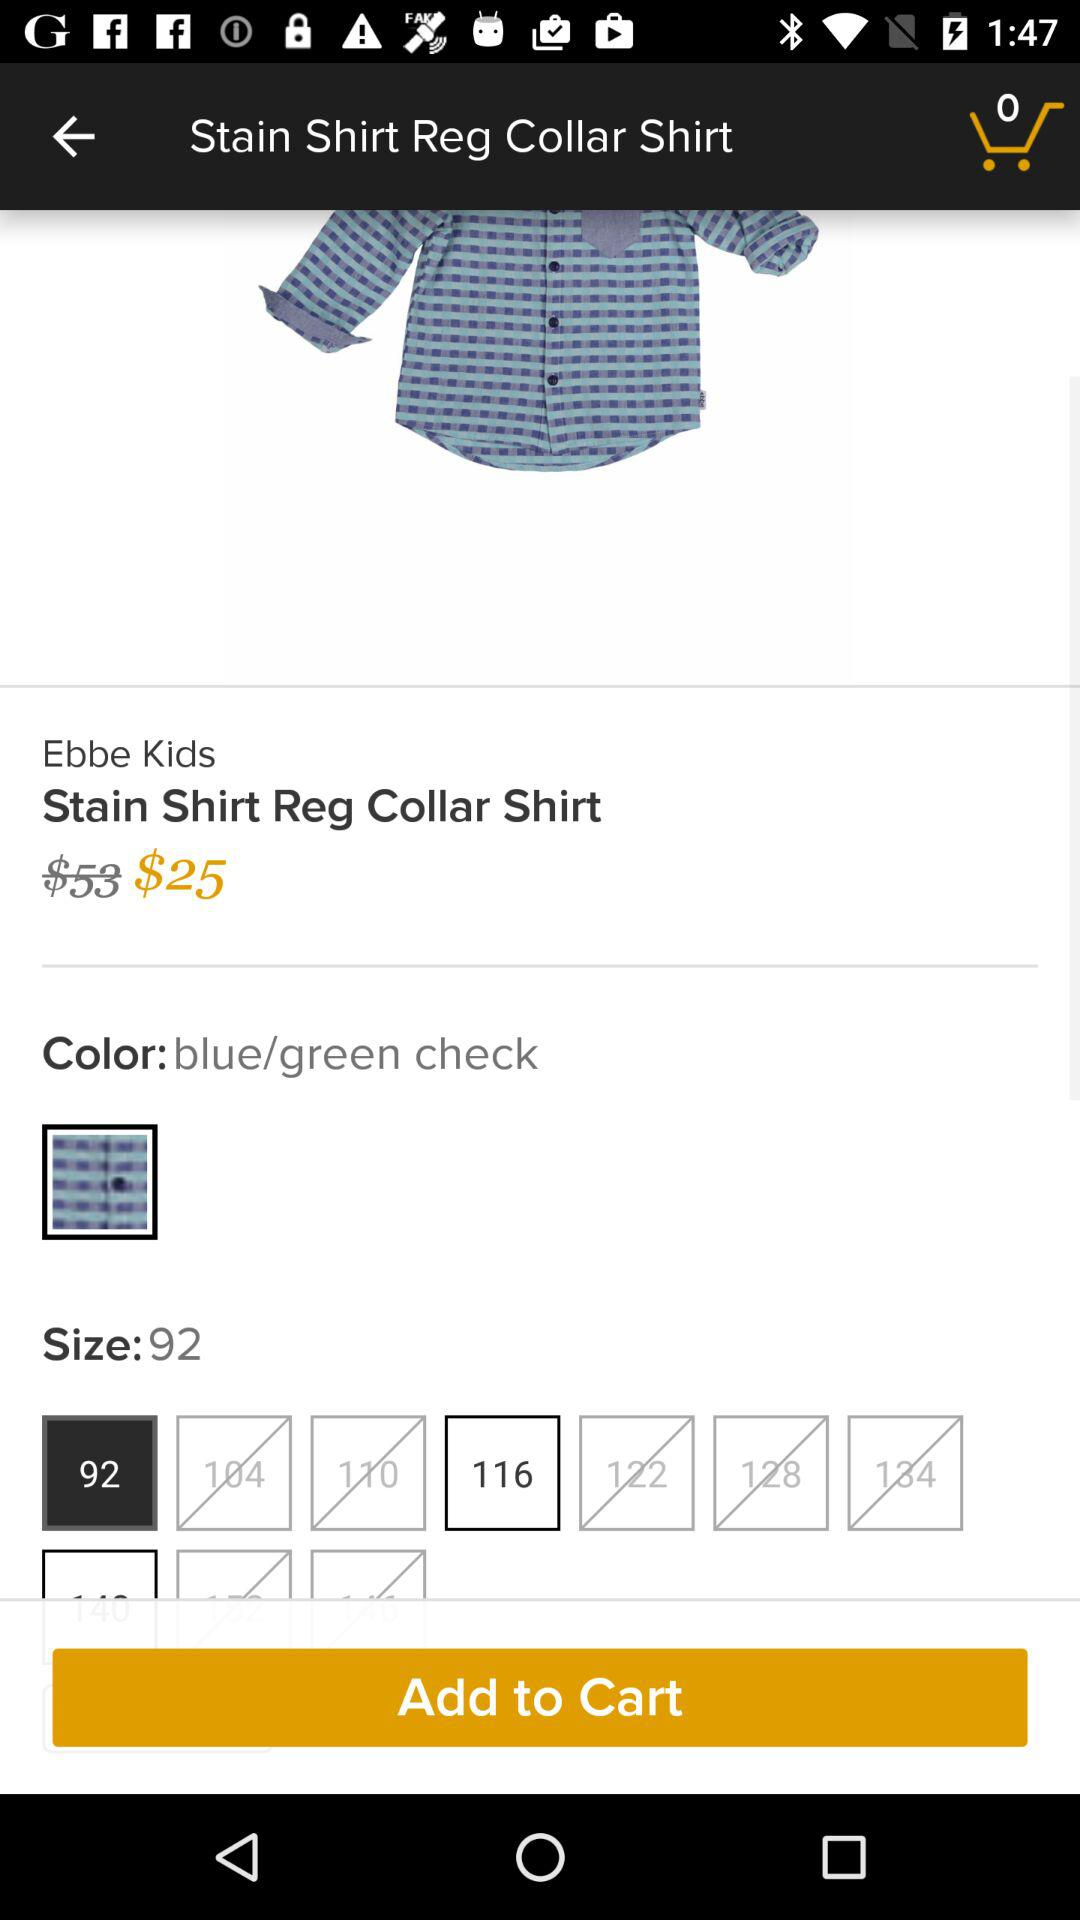How many sizes are available?
When the provided information is insufficient, respond with <no answer>. <no answer> 